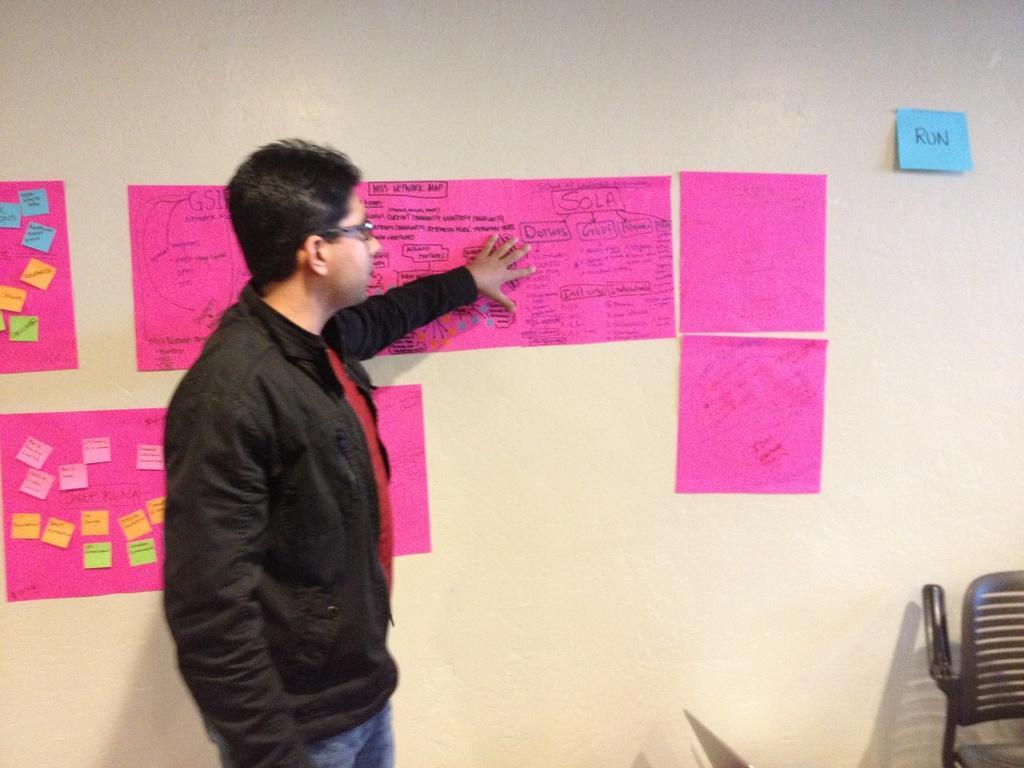Please provide a concise description of this image. In the center of the picture there is a person standing wearing a black jacket. On the right there is a chair. Behind the person there are charts attached to the wall. 